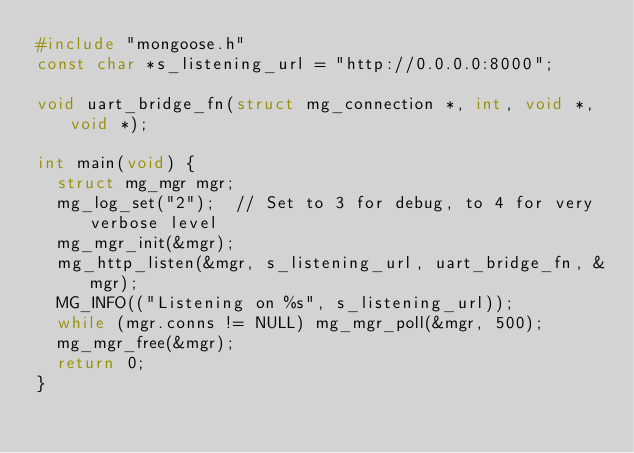<code> <loc_0><loc_0><loc_500><loc_500><_C_>#include "mongoose.h"
const char *s_listening_url = "http://0.0.0.0:8000";

void uart_bridge_fn(struct mg_connection *, int, void *, void *);

int main(void) {
  struct mg_mgr mgr;
  mg_log_set("2");  // Set to 3 for debug, to 4 for very verbose level
  mg_mgr_init(&mgr);
  mg_http_listen(&mgr, s_listening_url, uart_bridge_fn, &mgr);
  MG_INFO(("Listening on %s", s_listening_url));
  while (mgr.conns != NULL) mg_mgr_poll(&mgr, 500);
  mg_mgr_free(&mgr);
  return 0;
}
</code> 